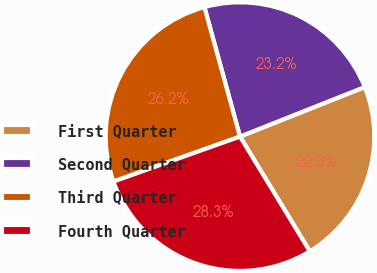Convert chart. <chart><loc_0><loc_0><loc_500><loc_500><pie_chart><fcel>First Quarter<fcel>Second Quarter<fcel>Third Quarter<fcel>Fourth Quarter<nl><fcel>22.32%<fcel>23.25%<fcel>26.17%<fcel>28.27%<nl></chart> 